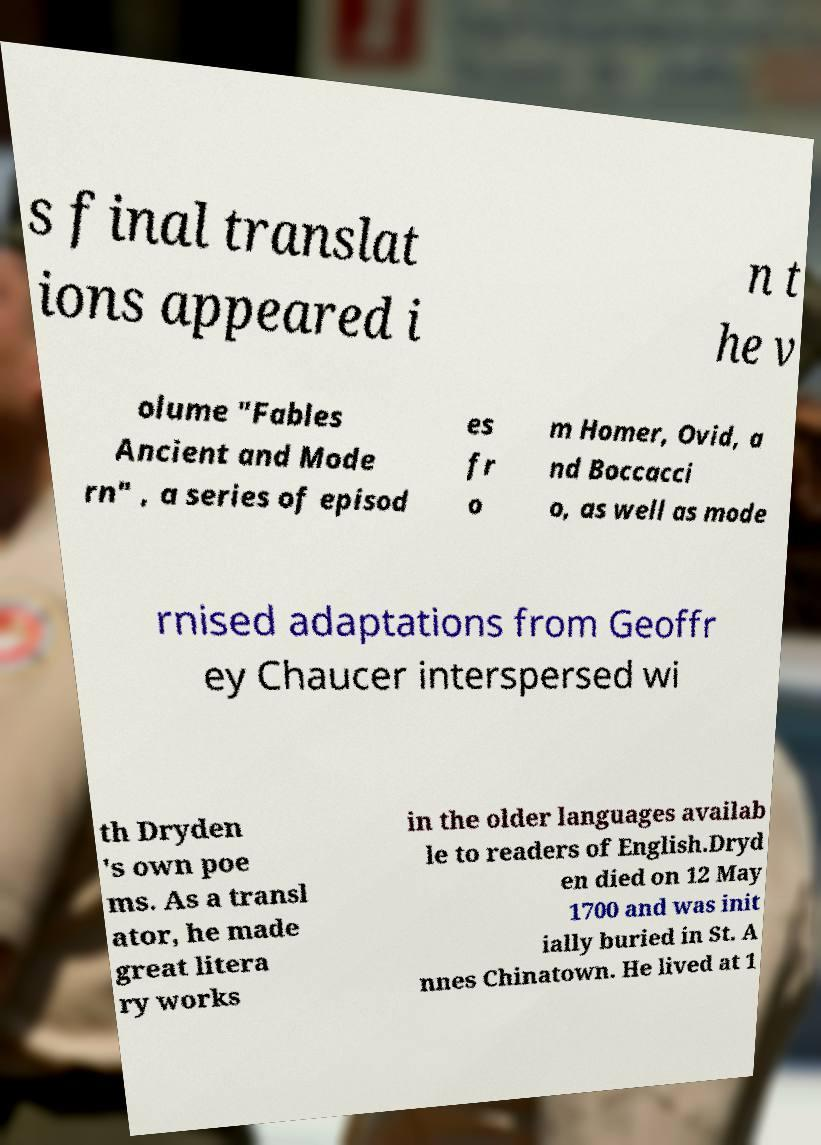Could you extract and type out the text from this image? s final translat ions appeared i n t he v olume "Fables Ancient and Mode rn" , a series of episod es fr o m Homer, Ovid, a nd Boccacci o, as well as mode rnised adaptations from Geoffr ey Chaucer interspersed wi th Dryden 's own poe ms. As a transl ator, he made great litera ry works in the older languages availab le to readers of English.Dryd en died on 12 May 1700 and was init ially buried in St. A nnes Chinatown. He lived at 1 